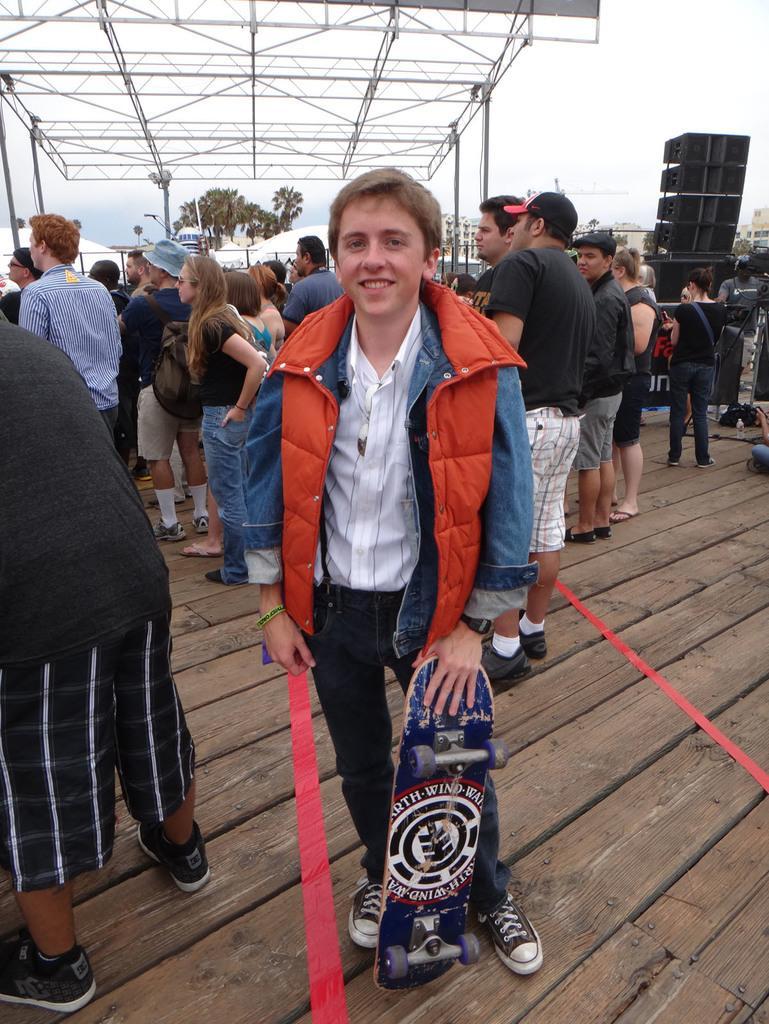Please provide a concise description of this image. In this image we can see a person standing on a wooden stage holding a skating board. On the backside we can see a group of people standing. We can also see some speakers, poles, trees and the sky which looks cloudy. 